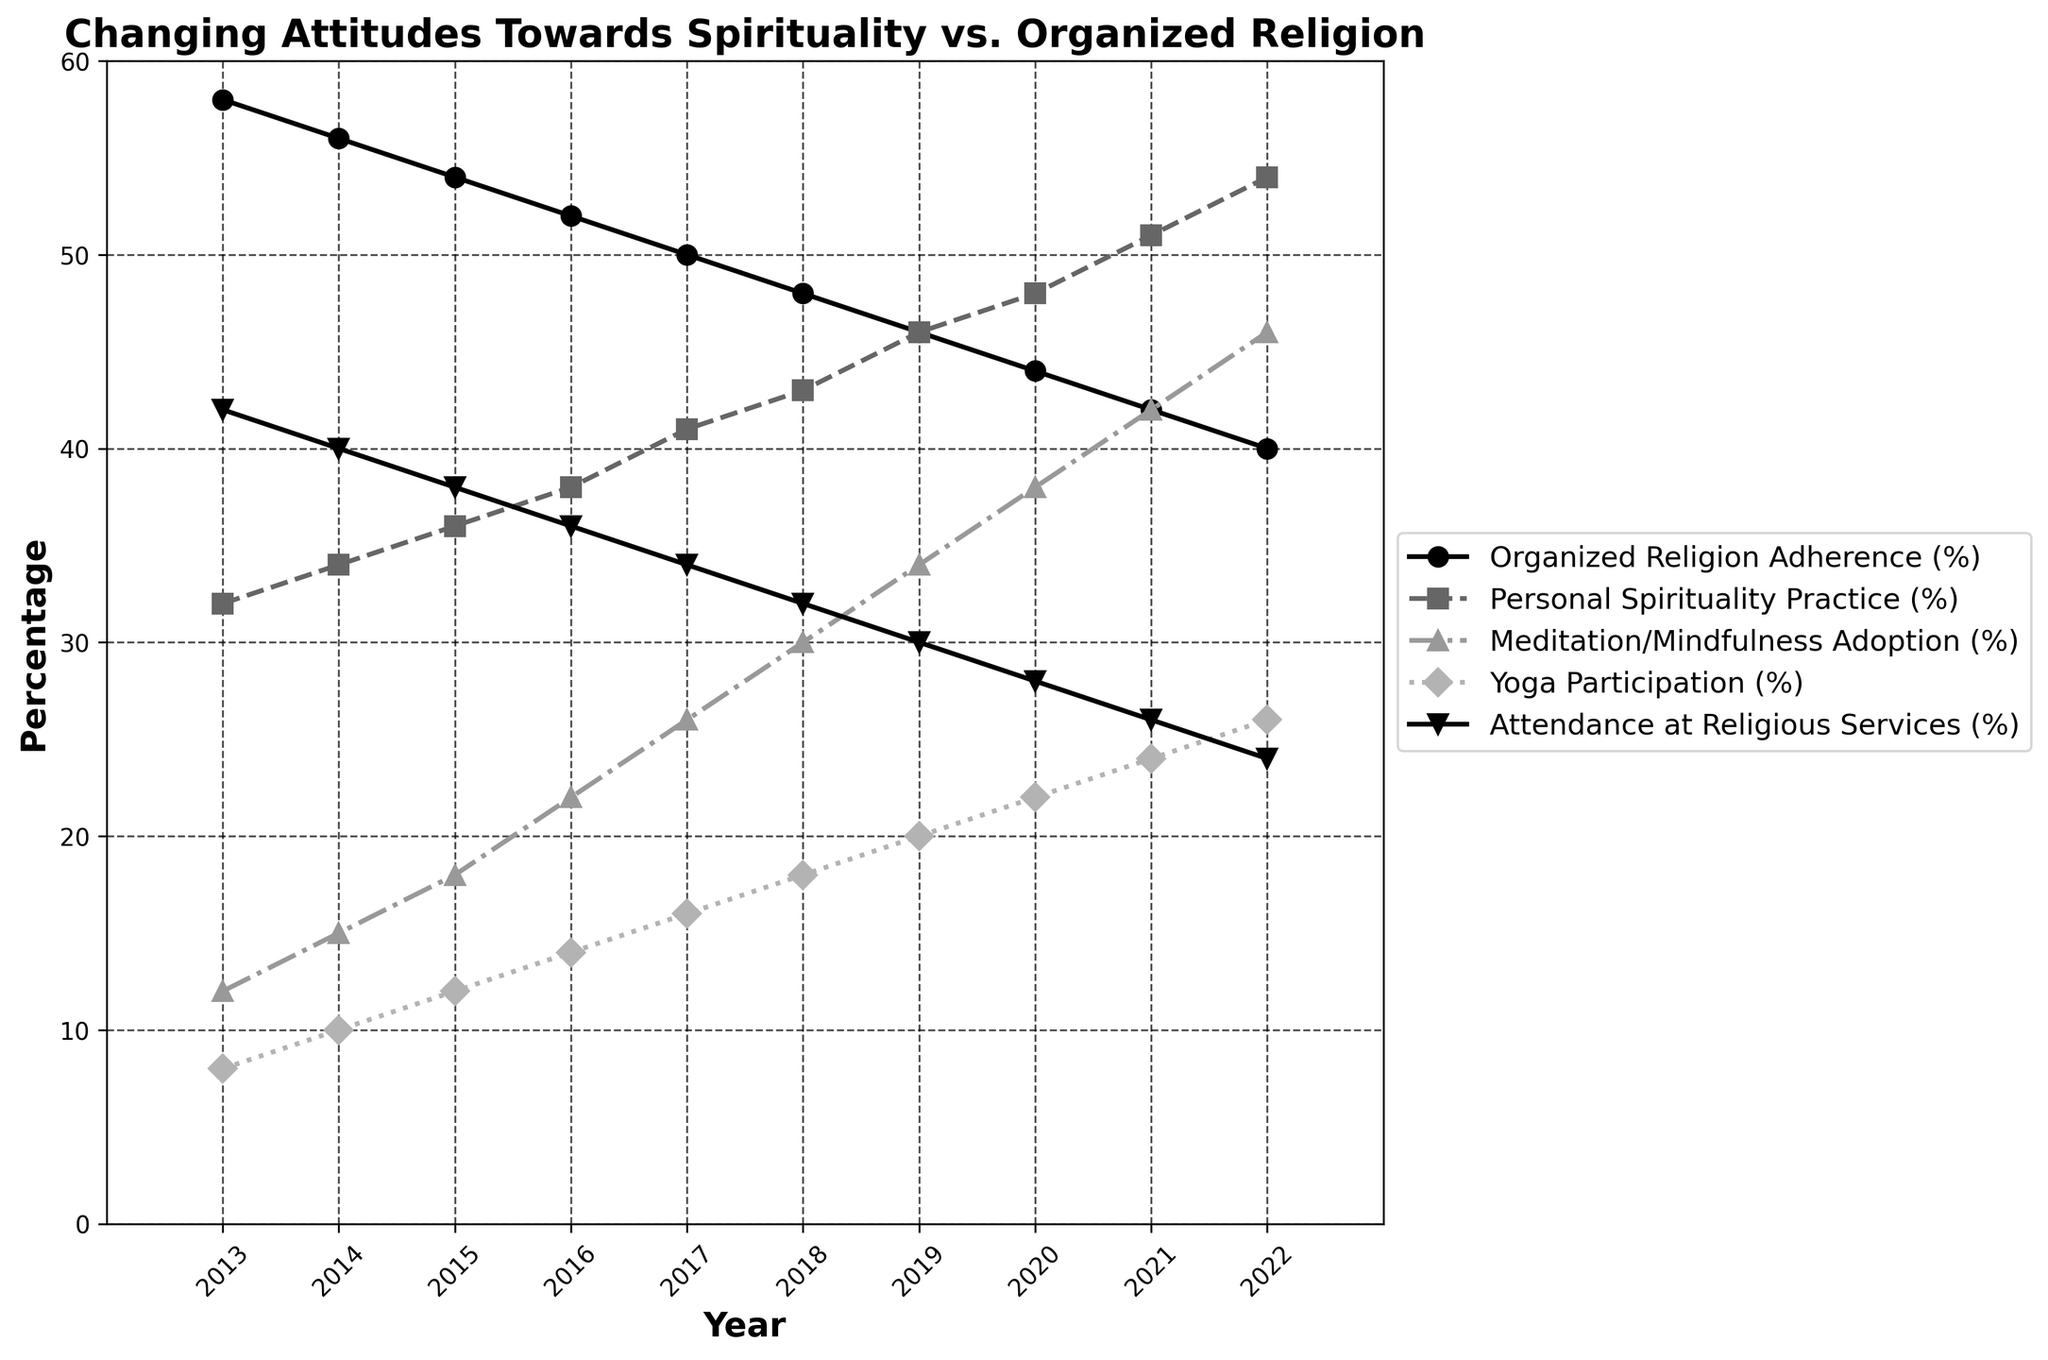What trend can be seen in Organized Religion Adherence over the decade? The chart shows a consistent decline in Organized Religion Adherence from 58% in 2013 to 40% in 2022.
Answer: Decline How much has Personal Spirituality Practice increased from 2013 to 2022? Personal Spirituality Practice increased from 32% in 2013 to 54% in 2022. To find the increase, subtract the 2013 value from the 2022 value: 54% - 32% = 22%.
Answer: 22% In which year did Meditation/Mindfulness Adoption overtake Attendance at Religious Services? By observing the chart, we see that in 2019, the percentage for Meditation/Mindfulness Adoption (34%) exceeds Attendance at Religious Services (30%).
Answer: 2019 Compare the trend of Yoga Participation and Attendance at Religious Services from 2013 to 2022. Yoga Participation shows a steady increase from 8% in 2013 to 26% in 2022, while Attendance at Religious Services shows a steady decline from 42% in 2013 to 24% in 2022.
Answer: Increase vs. Decline In which year was the gap between Personal Spirituality Practice and Organized Religion Adherence the largest? In 2022, Personal Spirituality Practice is 54% and Organized Religion Adherence is 40%. The gap is 54% - 40% = 14%. This is the largest gap observed.
Answer: 2022 What is the average Meditation/Mindfulness Adoption percentage over the decade? Sum the percentages from 2013 to 2022: 12 + 15 + 18 + 22 + 26 + 30 + 34 + 38 + 42 + 46 = 283. Then divide by the number of years, which is 10: 283 / 10 = 28.3%.
Answer: 28.3% Which year experienced the highest increase in Personal Spirituality Practice compared to the previous year? The largest yearly increase in Personal Spirituality Practice is from 2021 (51%) to 2022 (54%), which is an increase of 3%.
Answer: 2022 How does the trend in Meditation/Mindfulness Adoption compare to the trend in Yoga Participation? Both trends show a steady increase, but Meditation/Mindfulness Adoption increases at a faster rate than Yoga Participation.
Answer: Faster Increase for Meditation/Mindfulness What is the difference between Personal Spirituality Practice and Meditation/Mindfulness Adoption in 2022? In 2022, Personal Spirituality Practice is 54% versus Meditation/Mindfulness Adoption at 46%. The difference is 54% - 46% = 8%.
Answer: 8% How many times higher is the Yoga Participation percentage in 2022 compared to 2013? The Yoga Participation percentage in 2022 is 26% compared to 8% in 2013. The ratio is 26 / 8 = 3.25 times.
Answer: 3.25 times 